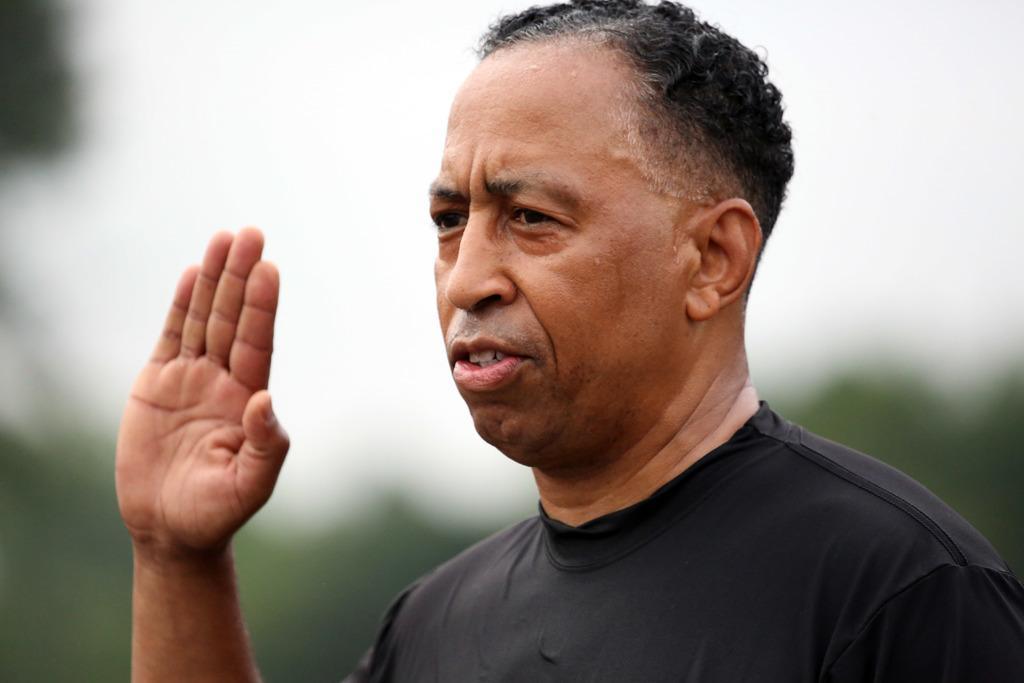How would you summarize this image in a sentence or two? In the image I can see a man is raising his hand. The man is wearing black color clothes. The background of the image is blurred. 